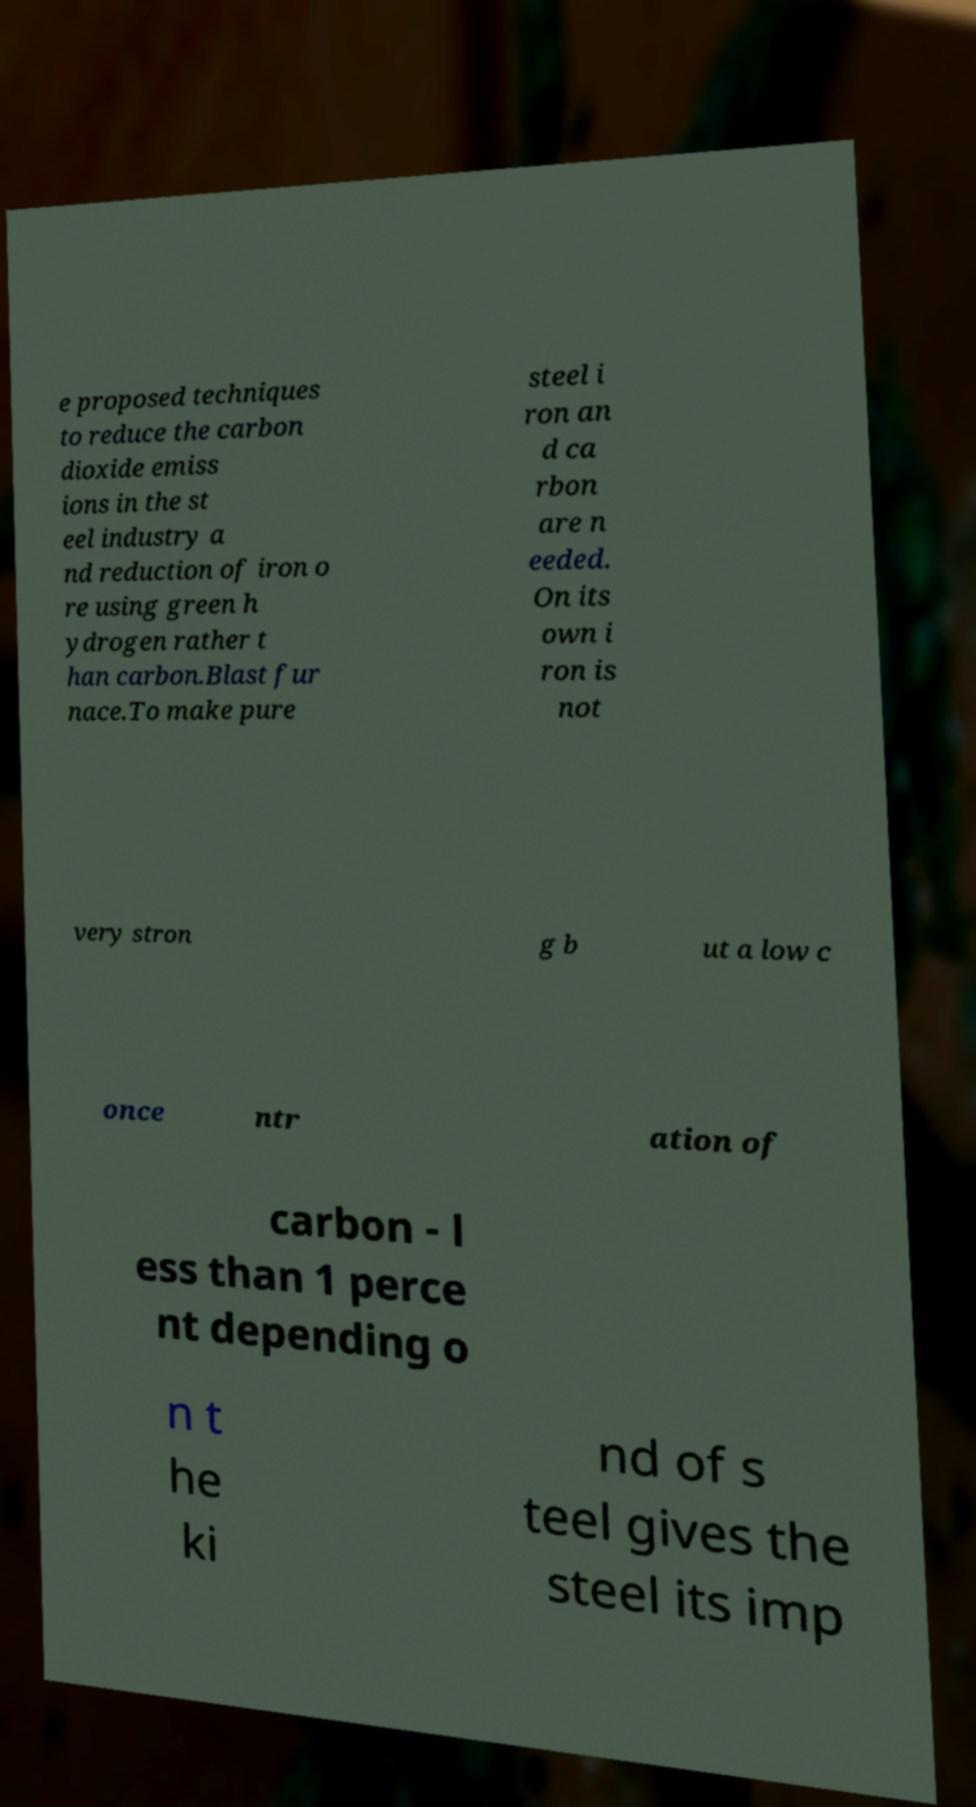For documentation purposes, I need the text within this image transcribed. Could you provide that? e proposed techniques to reduce the carbon dioxide emiss ions in the st eel industry a nd reduction of iron o re using green h ydrogen rather t han carbon.Blast fur nace.To make pure steel i ron an d ca rbon are n eeded. On its own i ron is not very stron g b ut a low c once ntr ation of carbon - l ess than 1 perce nt depending o n t he ki nd of s teel gives the steel its imp 